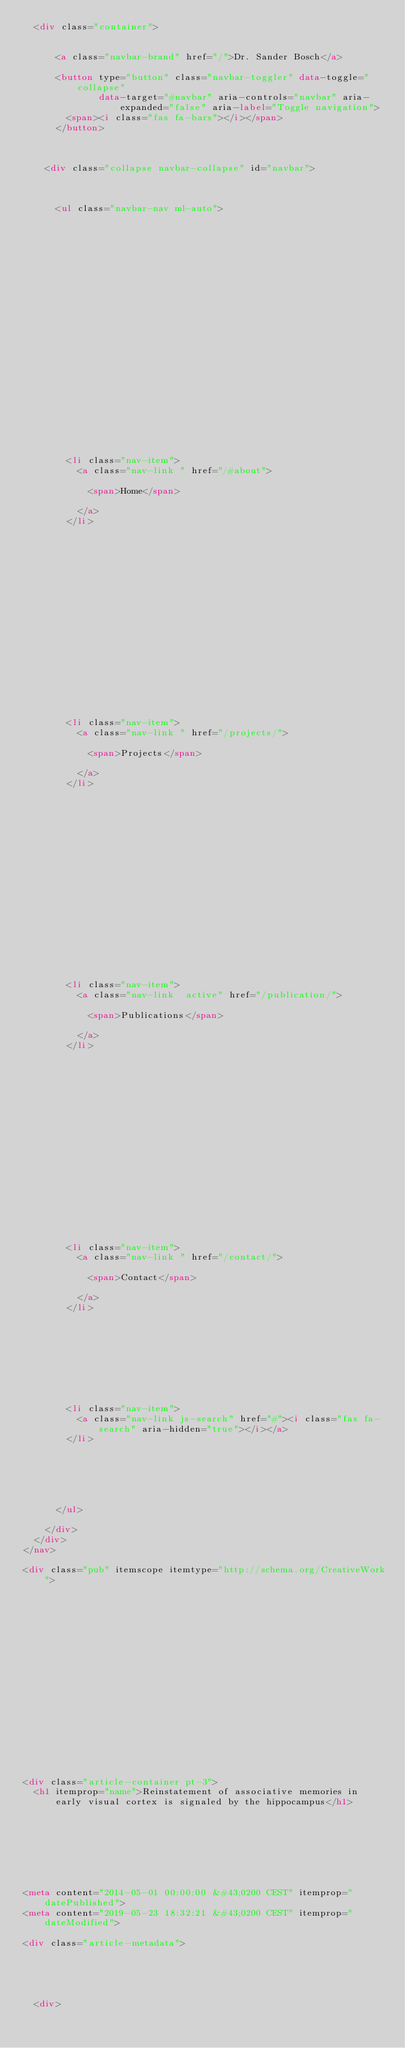<code> <loc_0><loc_0><loc_500><loc_500><_HTML_>  <div class="container">

    
      <a class="navbar-brand" href="/">Dr. Sander Bosch</a>
      
      <button type="button" class="navbar-toggler" data-toggle="collapse"
              data-target="#navbar" aria-controls="navbar" aria-expanded="false" aria-label="Toggle navigation">
        <span><i class="fas fa-bars"></i></span>
      </button>
      

    
    <div class="collapse navbar-collapse" id="navbar">

      
      
      <ul class="navbar-nav ml-auto">
        

        

        
        
        
          
        

        
        
        
        
        
        
          
          
          
            
          
          
        

        <li class="nav-item">
          <a class="nav-link " href="/#about">
            
            <span>Home</span>
            
          </a>
        </li>

        
        

        

        
        
        
          
        

        
        
        
        
        
        

        <li class="nav-item">
          <a class="nav-link " href="/projects/">
            
            <span>Projects</span>
            
          </a>
        </li>

        
        

        

        
        
        
          
        

        
        
        
        
        
        

        <li class="nav-item">
          <a class="nav-link  active" href="/publication/">
            
            <span>Publications</span>
            
          </a>
        </li>

        
        

        

        
        
        
          
        

        
        
        
        
        
        

        <li class="nav-item">
          <a class="nav-link " href="/contact/">
            
            <span>Contact</span>
            
          </a>
        </li>

        
        

      

        

        
        <li class="nav-item">
          <a class="nav-link js-search" href="#"><i class="fas fa-search" aria-hidden="true"></i></a>
        </li>
        

        

        

      </ul>

    </div>
  </div>
</nav>

<div class="pub" itemscope itemtype="http://schema.org/CreativeWork">

  












  

  
  
  
<div class="article-container pt-3">
  <h1 itemprop="name">Reinstatement of associative memories in early visual cortex is signaled by the hippocampus</h1>

  

  
    



<meta content="2014-05-01 00:00:00 &#43;0200 CEST" itemprop="datePublished">
<meta content="2019-05-23 18:32:21 &#43;0200 CEST" itemprop="dateModified">

<div class="article-metadata">

  
  
  
  
  <div>
    


</code> 